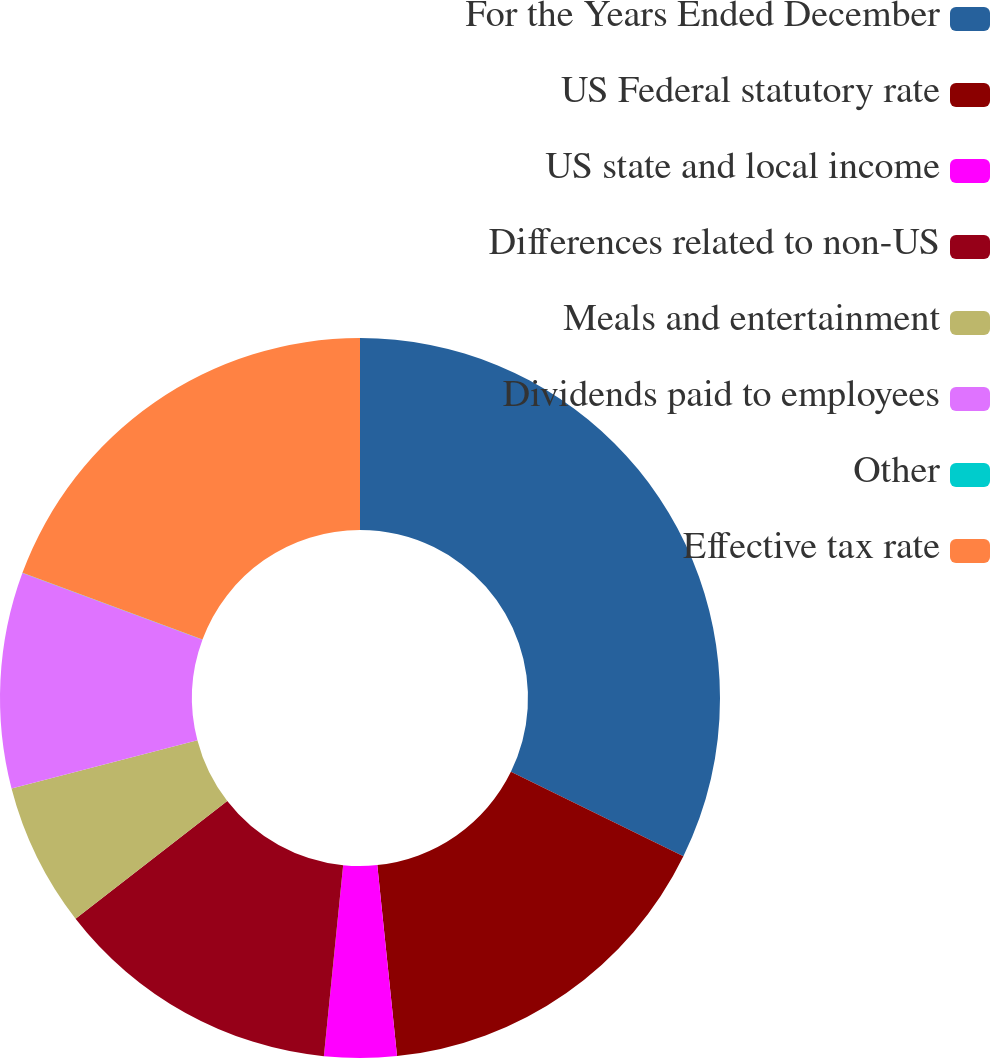Convert chart. <chart><loc_0><loc_0><loc_500><loc_500><pie_chart><fcel>For the Years Ended December<fcel>US Federal statutory rate<fcel>US state and local income<fcel>Differences related to non-US<fcel>Meals and entertainment<fcel>Dividends paid to employees<fcel>Other<fcel>Effective tax rate<nl><fcel>32.24%<fcel>16.12%<fcel>3.24%<fcel>12.9%<fcel>6.46%<fcel>9.68%<fcel>0.01%<fcel>19.35%<nl></chart> 